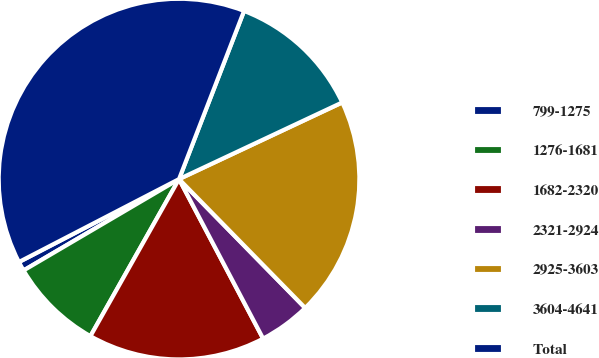Convert chart to OTSL. <chart><loc_0><loc_0><loc_500><loc_500><pie_chart><fcel>799-1275<fcel>1276-1681<fcel>1682-2320<fcel>2321-2924<fcel>2925-3603<fcel>3604-4641<fcel>Total<nl><fcel>0.85%<fcel>8.37%<fcel>15.9%<fcel>4.61%<fcel>19.66%<fcel>12.14%<fcel>38.48%<nl></chart> 